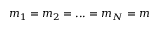Convert formula to latex. <formula><loc_0><loc_0><loc_500><loc_500>m _ { 1 } = m _ { 2 } = \dots = m _ { N } = m</formula> 